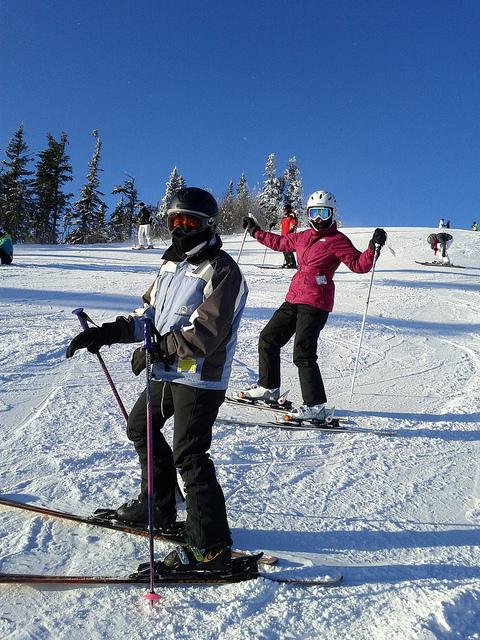Is it raining?
Quick response, please. No. How many people are skiing?
Give a very brief answer. 2. What are the two people doing on skis?
Keep it brief. Skiing. 